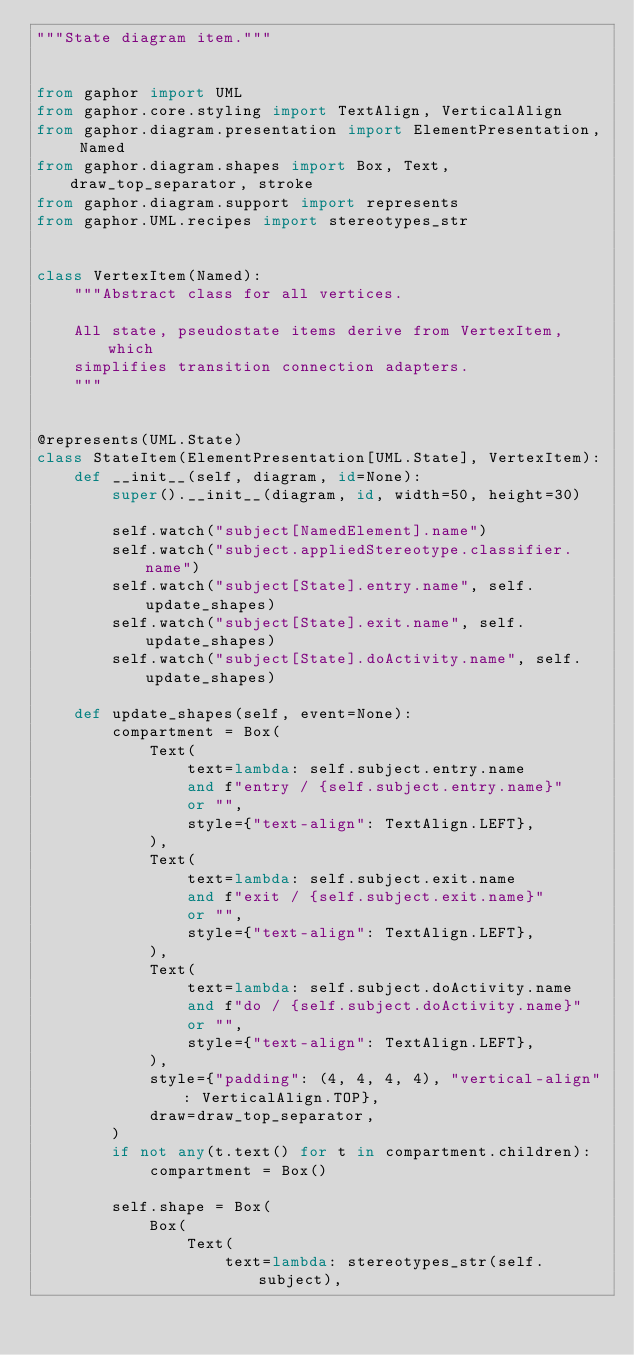<code> <loc_0><loc_0><loc_500><loc_500><_Python_>"""State diagram item."""


from gaphor import UML
from gaphor.core.styling import TextAlign, VerticalAlign
from gaphor.diagram.presentation import ElementPresentation, Named
from gaphor.diagram.shapes import Box, Text, draw_top_separator, stroke
from gaphor.diagram.support import represents
from gaphor.UML.recipes import stereotypes_str


class VertexItem(Named):
    """Abstract class for all vertices.

    All state, pseudostate items derive from VertexItem, which
    simplifies transition connection adapters.
    """


@represents(UML.State)
class StateItem(ElementPresentation[UML.State], VertexItem):
    def __init__(self, diagram, id=None):
        super().__init__(diagram, id, width=50, height=30)

        self.watch("subject[NamedElement].name")
        self.watch("subject.appliedStereotype.classifier.name")
        self.watch("subject[State].entry.name", self.update_shapes)
        self.watch("subject[State].exit.name", self.update_shapes)
        self.watch("subject[State].doActivity.name", self.update_shapes)

    def update_shapes(self, event=None):
        compartment = Box(
            Text(
                text=lambda: self.subject.entry.name
                and f"entry / {self.subject.entry.name}"
                or "",
                style={"text-align": TextAlign.LEFT},
            ),
            Text(
                text=lambda: self.subject.exit.name
                and f"exit / {self.subject.exit.name}"
                or "",
                style={"text-align": TextAlign.LEFT},
            ),
            Text(
                text=lambda: self.subject.doActivity.name
                and f"do / {self.subject.doActivity.name}"
                or "",
                style={"text-align": TextAlign.LEFT},
            ),
            style={"padding": (4, 4, 4, 4), "vertical-align": VerticalAlign.TOP},
            draw=draw_top_separator,
        )
        if not any(t.text() for t in compartment.children):
            compartment = Box()

        self.shape = Box(
            Box(
                Text(
                    text=lambda: stereotypes_str(self.subject),</code> 